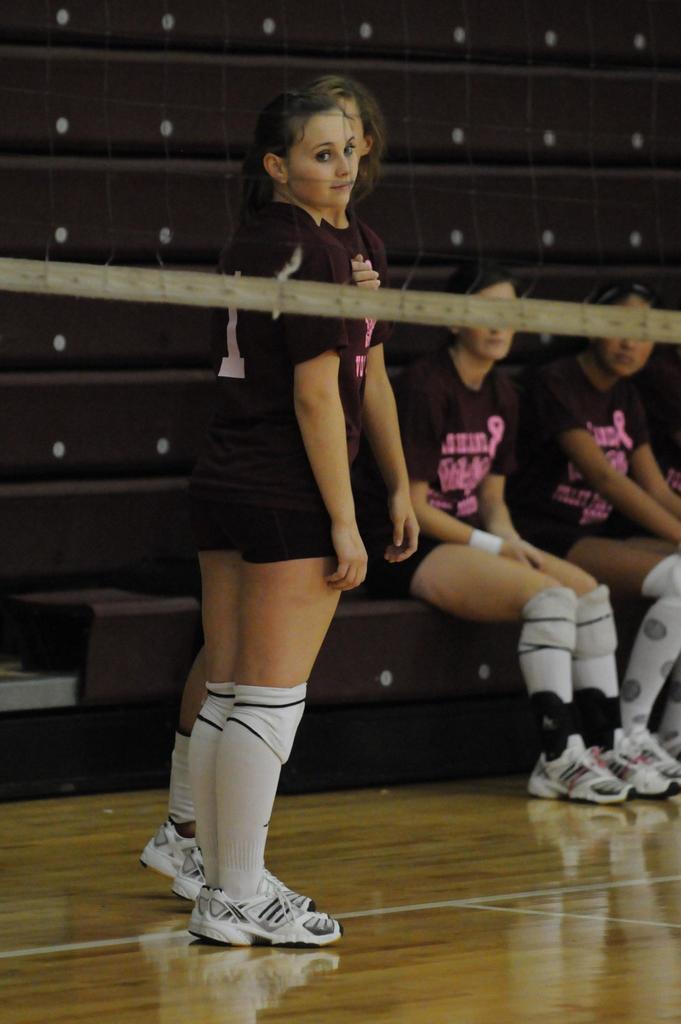How would you summarize this image in a sentence or two? In the picture we can see two women are standing on the wooden surface, they are wearing a brown color sports wear and behind them, we can see some women are sitting and they are also wearing a brown color sportswear and in the background we can see a wall which is brown in color with white dots on it. 